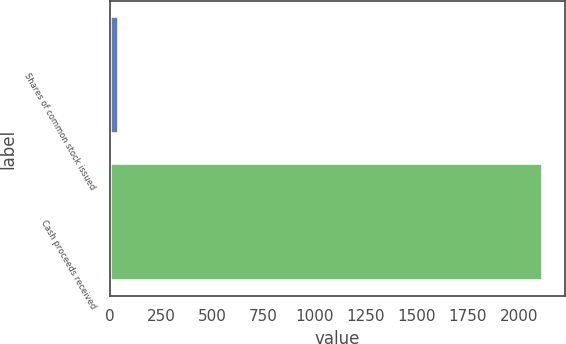Convert chart. <chart><loc_0><loc_0><loc_500><loc_500><bar_chart><fcel>Shares of common stock issued<fcel>Cash proceeds received<nl><fcel>44<fcel>2119<nl></chart> 